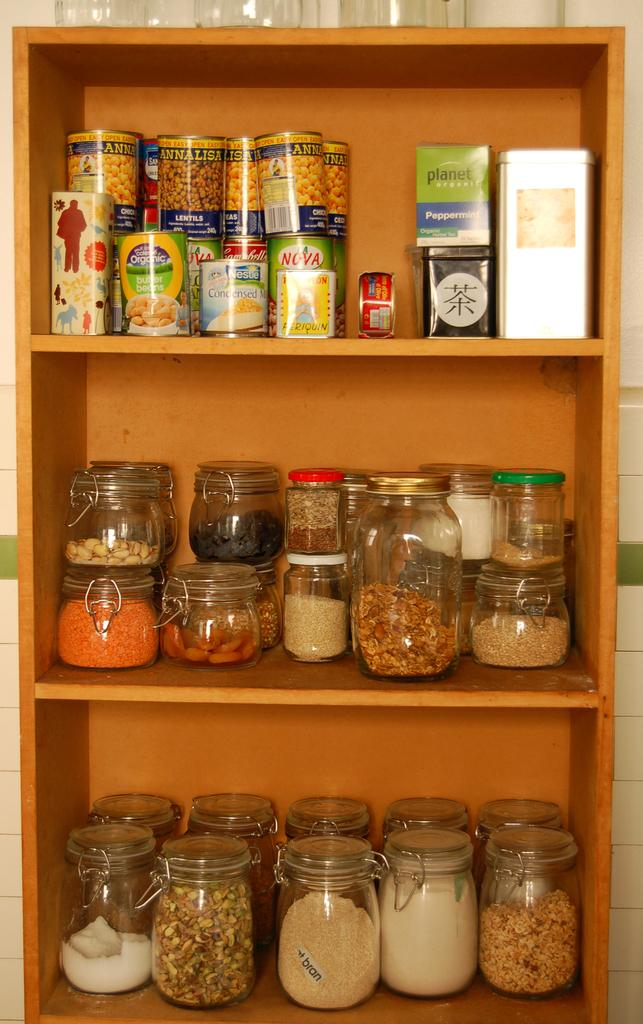What objects are present in the image? There are containers in the image. Where are the containers located? The containers are in a shelf. What type of sugar is being used to create humor in the image? There is no sugar or humor present in the image; it only features containers on a shelf. 